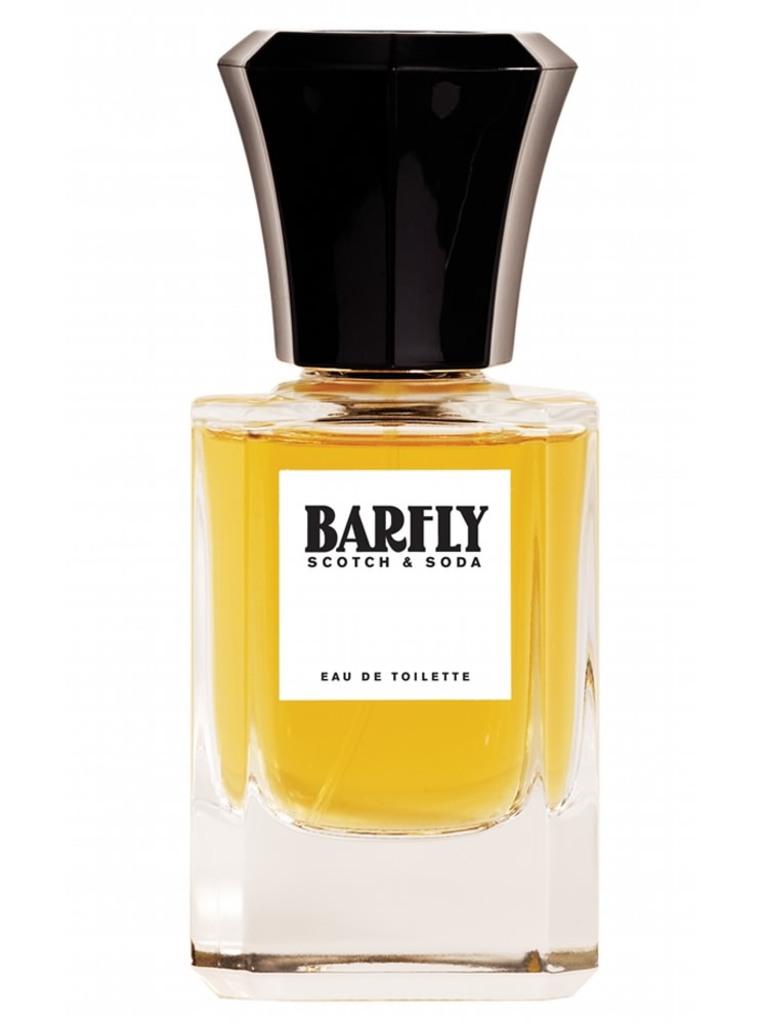What brand is that?
Offer a terse response. Barfly. Is this scotch?
Provide a succinct answer. Yes. 